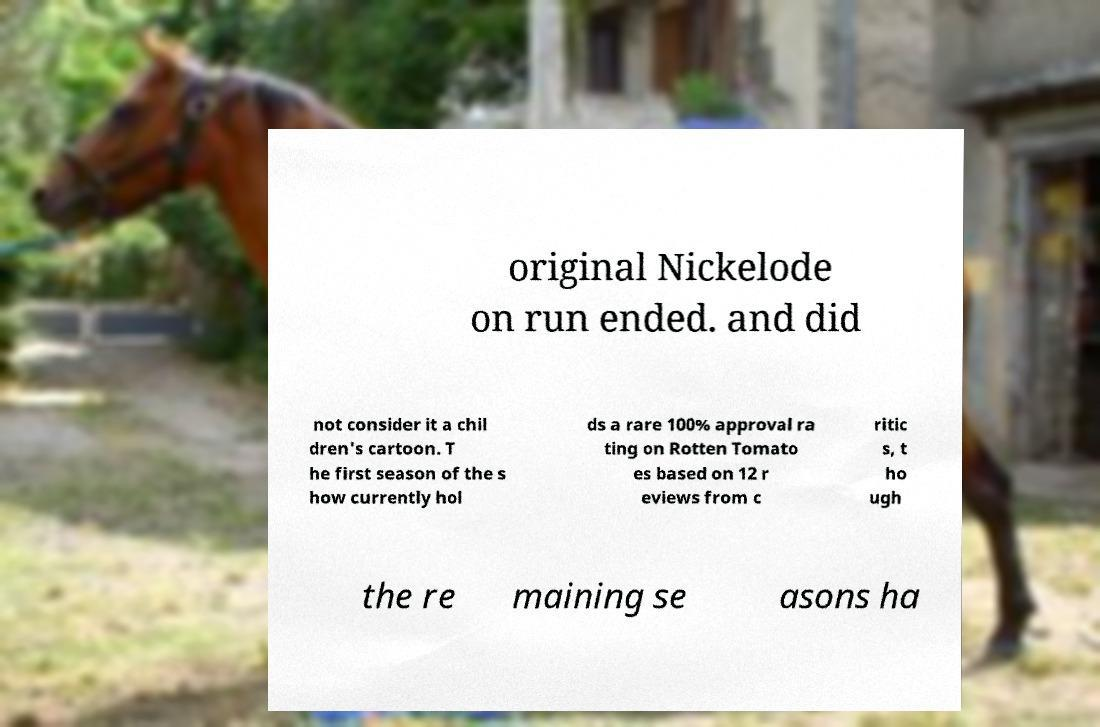Can you read and provide the text displayed in the image?This photo seems to have some interesting text. Can you extract and type it out for me? original Nickelode on run ended. and did not consider it a chil dren's cartoon. T he first season of the s how currently hol ds a rare 100% approval ra ting on Rotten Tomato es based on 12 r eviews from c ritic s, t ho ugh the re maining se asons ha 